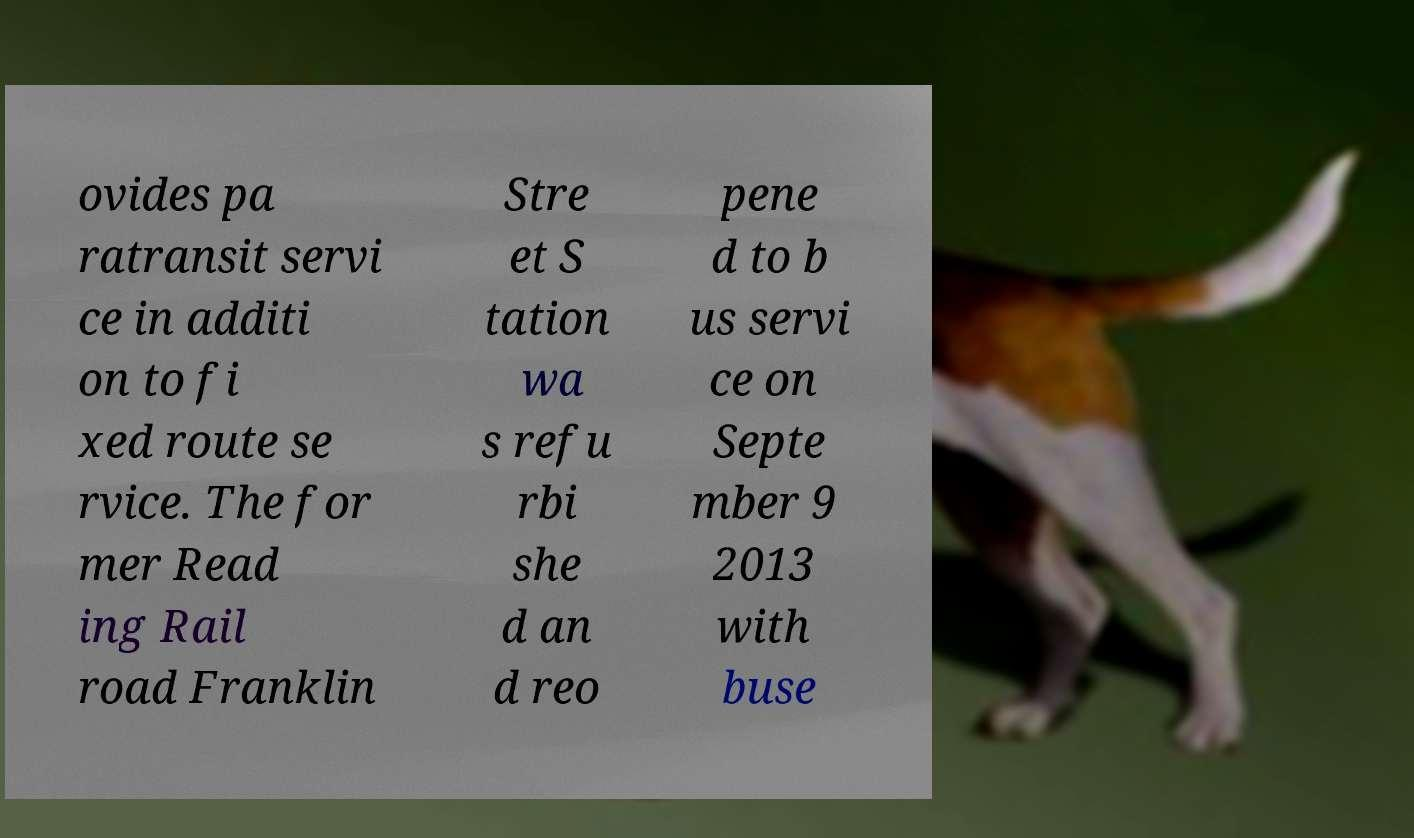There's text embedded in this image that I need extracted. Can you transcribe it verbatim? ovides pa ratransit servi ce in additi on to fi xed route se rvice. The for mer Read ing Rail road Franklin Stre et S tation wa s refu rbi she d an d reo pene d to b us servi ce on Septe mber 9 2013 with buse 